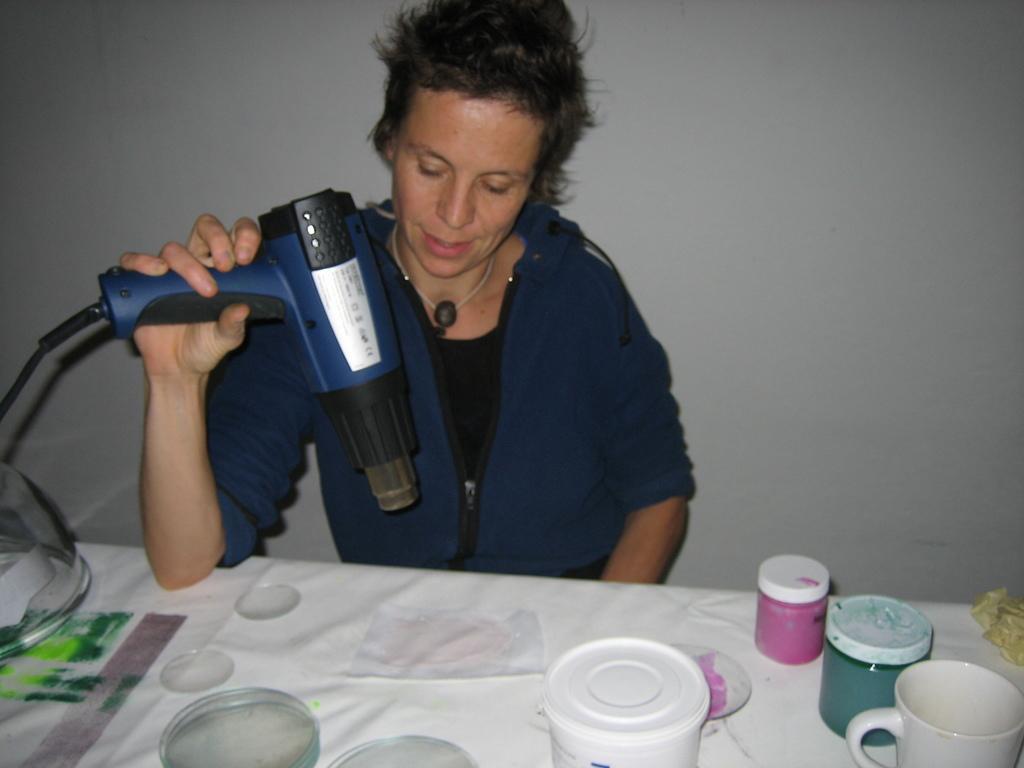Can you describe this image briefly? In this image in the center there is a table which is covered with the white colour cloth. On the table there are bottles and there is a cup. Behind the table there is a woman sitting and holding a machine in her hand and smiling. 